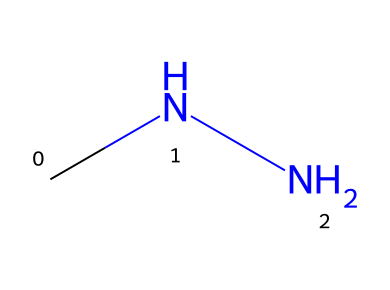What is the molecular formula of monomethylhydrazine? The SMILES representation "CNN" indicates that the compound consists of two nitrogen atoms and six hydrogen atoms, resulting in the molecular formula C2H8N2.
Answer: C2H8N2 How many carbon atoms are present in monomethylhydrazine? The SMILES structure "CNN" shows that there is one "C" represented, indicating there is one carbon atom in the molecule.
Answer: 1 What type of functional group is present in monomethylhydrazine? The presence of two nitrogen atoms in the structure "CNN" indicates that it belongs to the hydrazine functional group, characterized by the R-NH-NH-R structure.
Answer: hydrazine What is the hybridization of the nitrogen atoms in monomethylhydrazine? The nitrogen atoms in the "CNN" structure form two single bonds and one lone pair, indicating the nitrogen atoms are sp3 hybridized.
Answer: sp3 What type of bonding is primarily present in monomethylhydrazine? The connections in the SMILES representation "CNN" imply that there are single covalent bonds between the carbon and nitrogen atoms.
Answer: single covalent What kind of chemical reactivity might monomethylhydrazine have due to its structure? The presence of the nitrogen-nitrogen bond in "CNN" suggests that it can participate in redox reactions and nucleophilic substitutions due to its ability to donate electrons.
Answer: redox reactions What is the primary application of monomethylhydrazine in modern pharmaceuticals? Monomethylhydrazine is used as a propellant in rocket fuels, but its derivatives are researched for their potential in stress-relief medications due to their interactive properties with biological systems.
Answer: propellant 